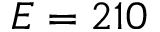Convert formula to latex. <formula><loc_0><loc_0><loc_500><loc_500>E = 2 1 0</formula> 